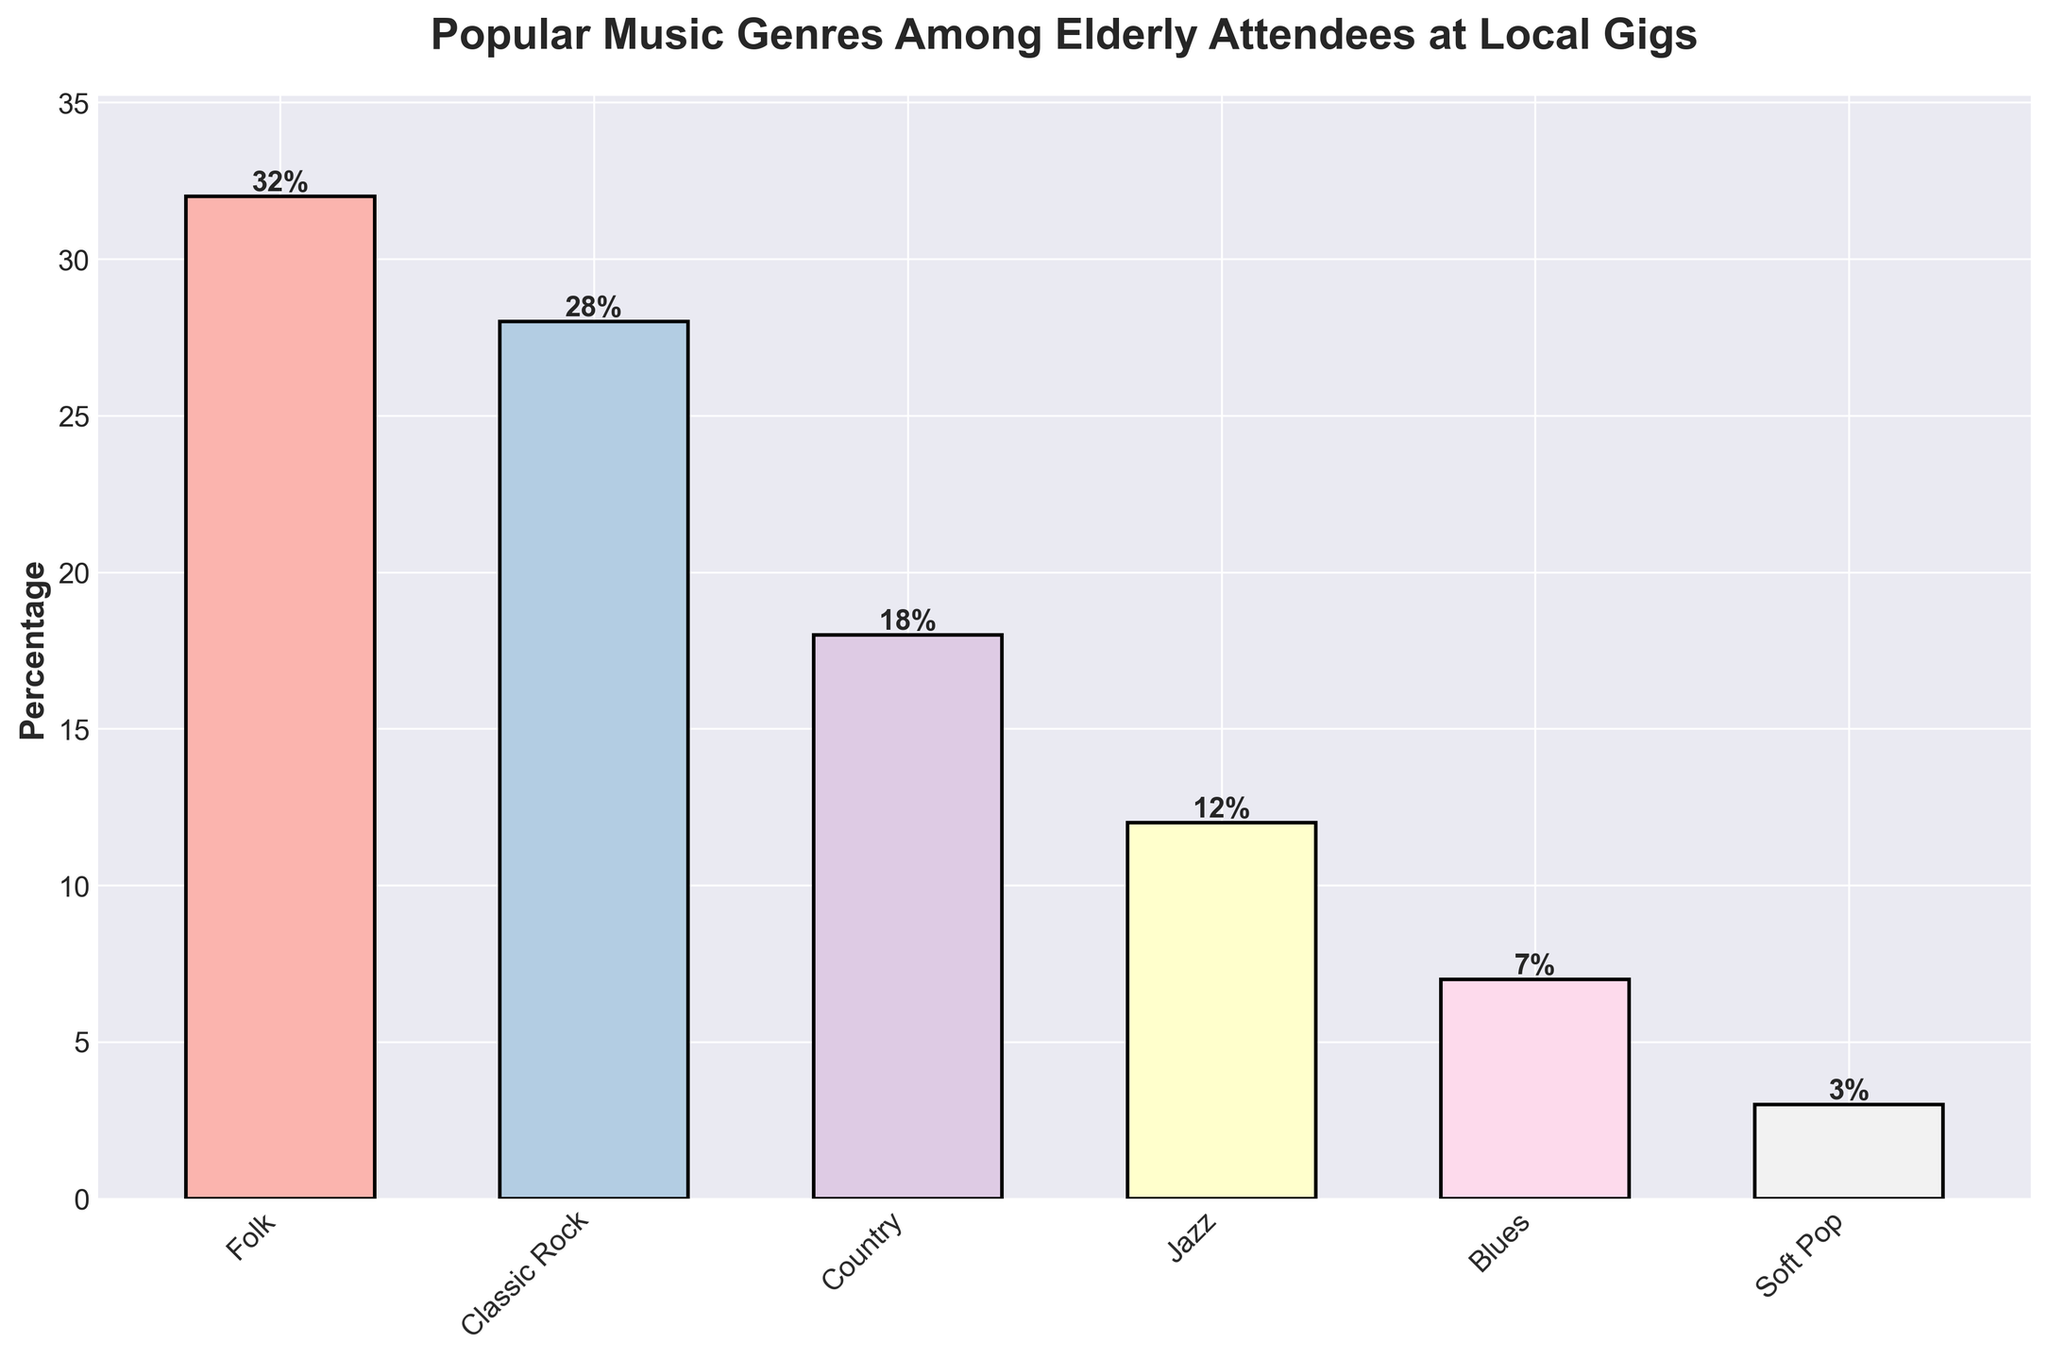What's the most popular music genre among elderly attendees at local gigs? The highest bar in the chart represents the most popular genre, which reaches up to 32%.
Answer: Folk Which genre is more popular, Classic Rock or Jazz? By comparing the height of the bars, Classic Rock has a percentage of 28%, while Jazz has 12%. Classic Rock is higher.
Answer: Classic Rock What's the total percentage of attendees who prefer Country and Blues combined? Add the percentages for Country (18%) and Blues (7%). 18 + 7 = 25
Answer: 25% How much more popular is Folk music compared to Soft Pop music? Subtract the percentage of Soft Pop (3%) from Folk (32%). 32 - 3 = 29
Answer: 29% Which genre has the smallest percentage of elderly attendees? The smallest bar in the chart represents Soft Pop, which has a percentage of 3%.
Answer: Soft Pop What is the average percentage of the three least popular genres? Find the percentages for Country (18%), Jazz (12%), and Blues (7%). Add them up: 18 + 12 + 7 = 37, then divide by 3. 37 / 3 ≈ 12.33
Answer: 12.33% Are there more attendees who prefer Classic Rock than the total attendees who prefer Blues and Jazz combined? Sum the percentages for Blues (7%) and Jazz (12%). 7 + 12 = 19. Compare this with Classic Rock (28%). 28 is greater than 19.
Answer: Yes What's the difference in percentage points between the most and least popular genres? Subtract the percentage of Soft Pop (3%) from Folk (32%). 32 - 3 = 29
Answer: 29 Which genres have a percentage below 10%? Check the bars below 10%: Blues (7%) and Soft Pop (3%).
Answer: Blues, Soft Pop What's the combined percentage of attendees interested in the top two genres? Add the percentages for Folk (32%) and Classic Rock (28%). 32 + 28 = 60
Answer: 60% 